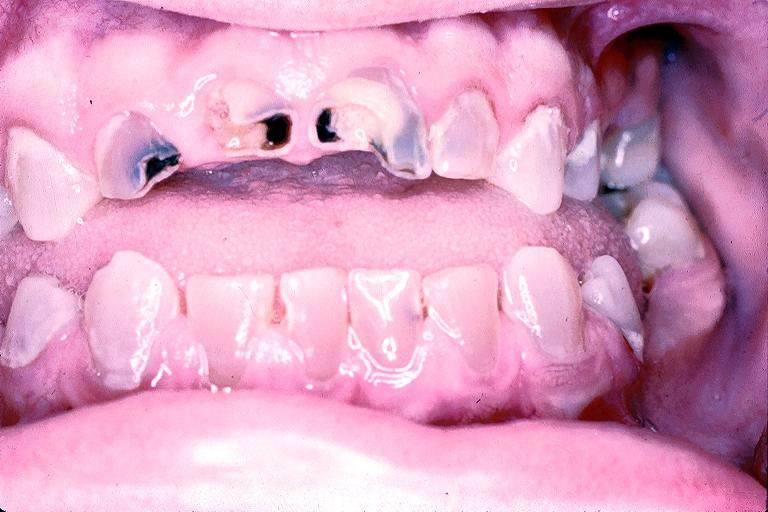what is present?
Answer the question using a single word or phrase. Oral 